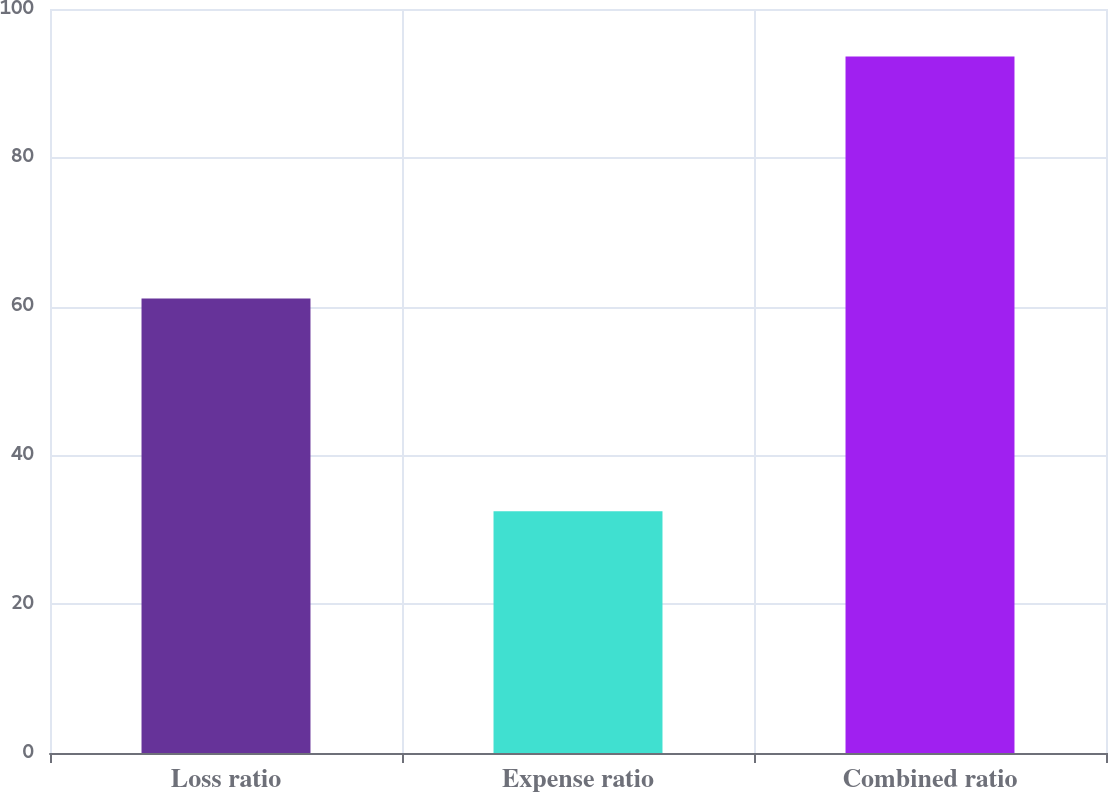Convert chart. <chart><loc_0><loc_0><loc_500><loc_500><bar_chart><fcel>Loss ratio<fcel>Expense ratio<fcel>Combined ratio<nl><fcel>61.1<fcel>32.5<fcel>93.6<nl></chart> 